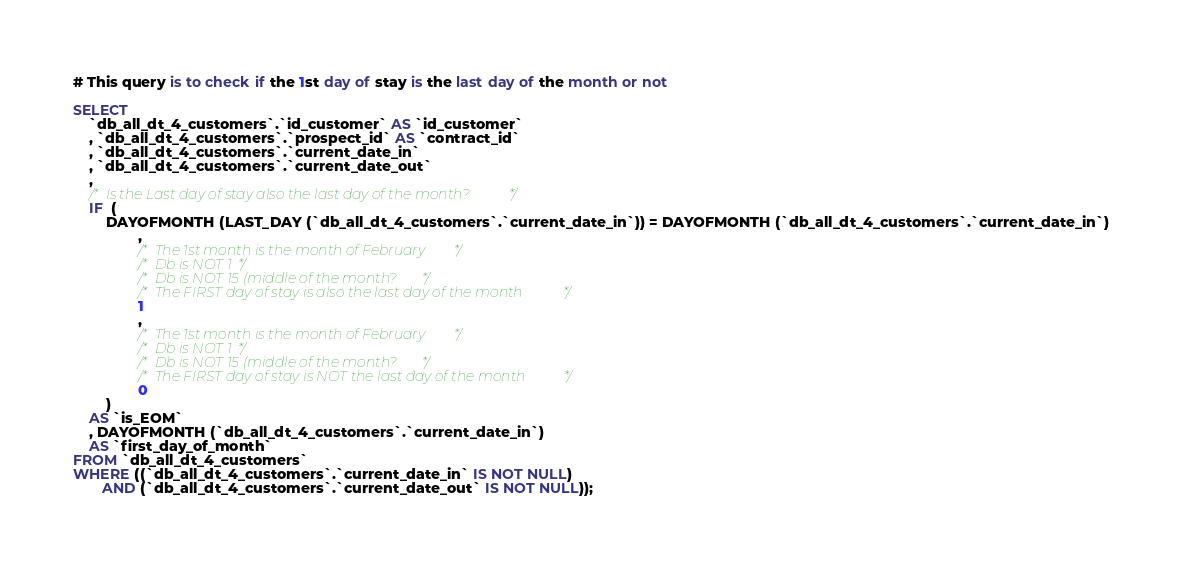<code> <loc_0><loc_0><loc_500><loc_500><_SQL_># This query is to check if the 1st day of stay is the last day of the month or not

SELECT
	`db_all_dt_4_customers`.`id_customer` AS `id_customer`
	, `db_all_dt_4_customers`.`prospect_id` AS `contract_id`
	, `db_all_dt_4_customers`.`current_date_in`
	, `db_all_dt_4_customers`.`current_date_out`
	, 
	/* Is the Last day of stay also the last day of the month? */
	IF  ( 
		DAYOFMONTH (LAST_DAY (`db_all_dt_4_customers`.`current_date_in`)) = DAYOFMONTH (`db_all_dt_4_customers`.`current_date_in`)
				, 
				/* The 1st month is the month of February */
				/* Db is NOT 1*/
				/* Db is NOT 15 (middle of the month? */
				/* The FIRST day of stay is also the last day of the month */
				1
				,
				/* The 1st month is the month of February */
				/* Db is NOT 1*/
				/* Db is NOT 15 (middle of the month? */
				/* The FIRST day of stay is NOT the last day of the month */
				0
		)	
	AS `is_EOM`
	, DAYOFMONTH (`db_all_dt_4_customers`.`current_date_in`) 
	AS `first_day_of_month`
FROM `db_all_dt_4_customers`
WHERE ((`db_all_dt_4_customers`.`current_date_in` IS NOT NULL)
       AND (`db_all_dt_4_customers`.`current_date_out` IS NOT NULL));</code> 